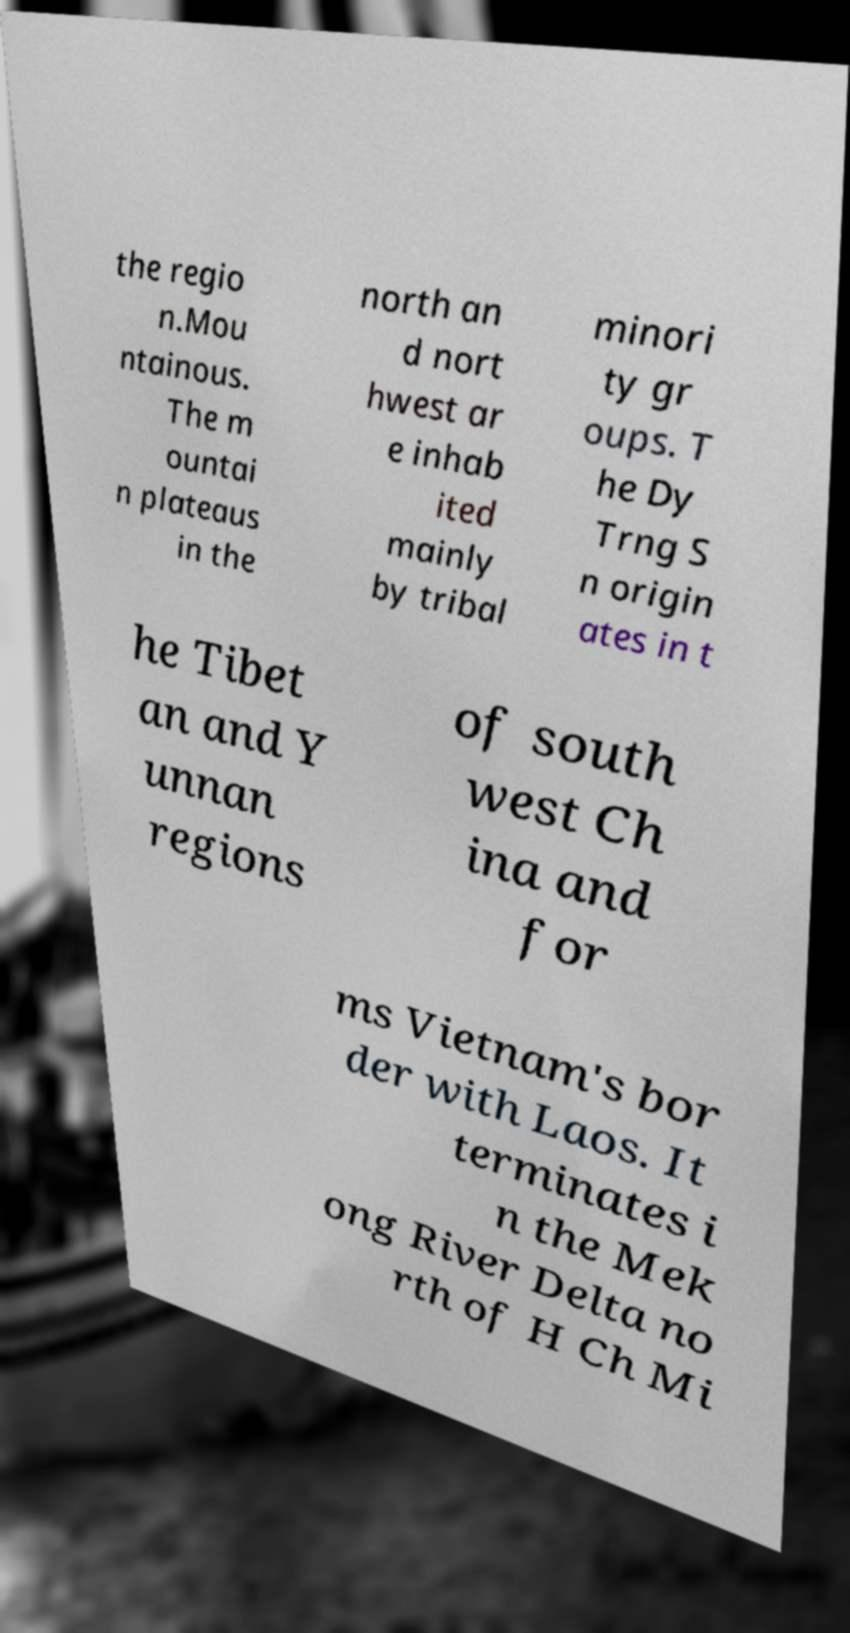There's text embedded in this image that I need extracted. Can you transcribe it verbatim? the regio n.Mou ntainous. The m ountai n plateaus in the north an d nort hwest ar e inhab ited mainly by tribal minori ty gr oups. T he Dy Trng S n origin ates in t he Tibet an and Y unnan regions of south west Ch ina and for ms Vietnam's bor der with Laos. It terminates i n the Mek ong River Delta no rth of H Ch Mi 